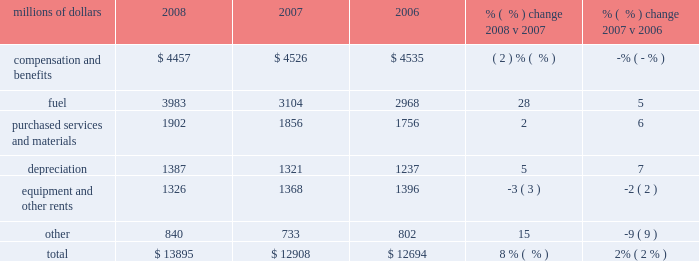Volume declines in cement , some agricultural products , and newsprint shipments partially offset the increases .
Operating expenses millions of dollars 2008 2007 2006 % (  % ) change 2008 v 2007 % (  % ) change 2007 v 2006 .
Operating expenses increased $ 987 million in 2008 .
Our fuel price per gallon rose 39% ( 39 % ) during the year , increasing operating expenses by $ 1.1 billion compared to 2007 .
Wage , benefit , and materials inflation , higher depreciation , and costs associated with the january cascade mudslide and hurricanes gustav and ike also increased expenses during the year .
Cost savings from productivity improvements , better resource utilization , and lower volume helped offset these increases .
Operating expenses increased $ 214 million in 2007 versus 2006 .
Higher fuel prices , which rose 9% ( 9 % ) during the period , increased operating expenses by $ 242 million .
Wage , benefit and materials inflation and higher depreciation expense also increased expenses during the year .
Productivity improvements , better resource utilization , and a lower fuel consumption rate helped offset these increases .
Compensation and benefits 2013 compensation and benefits include wages , payroll taxes , health and welfare costs , pension costs , other postretirement benefits , and incentive costs .
Productivity initiatives in all areas , combined with lower volume , led to a 4% ( 4 % ) decline in our workforce for 2008 , saving $ 227 million compared to 2007 .
Conversely , general wage and benefit inflation and higher pension and postretirement benefits increased expenses in 2008 , partially offsetting these reductions .
Operational improvements and lower volume levels in 2007 led to a 1% ( 1 % ) decline in our workforce , saving $ 79 million in 2007 compared to 2006 .
A smaller workforce and less need for new train personnel reduced training costs during the year , which contributed to the improvement .
General wage and benefit inflation mostly offset the reductions , reflecting higher salaries and wages and the impact of higher healthcare and other benefit costs .
Fuel 2013 fuel includes locomotive fuel and gasoline for highway and non-highway vehicles and heavy equipment .
Diesel fuel prices , which averaged $ 3.15 per gallon ( including taxes and transportation costs ) in 2008 compared to $ 2.27 per gallon in 2007 , increased expenses by $ 1.1 billion .
A 4% ( 4 % ) improvement in our fuel consumption rate resulted in $ 136 million of cost savings due to the use of newer , more fuel 2008 operating expenses .
What percent of total operating expenses was fuel in 2008? 
Computations: (3983 / 13895)
Answer: 0.28665. 